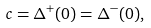<formula> <loc_0><loc_0><loc_500><loc_500>c = \Delta ^ { + } ( 0 ) = \Delta ^ { - } ( 0 ) ,</formula> 